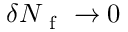<formula> <loc_0><loc_0><loc_500><loc_500>\delta N _ { f } \to 0</formula> 